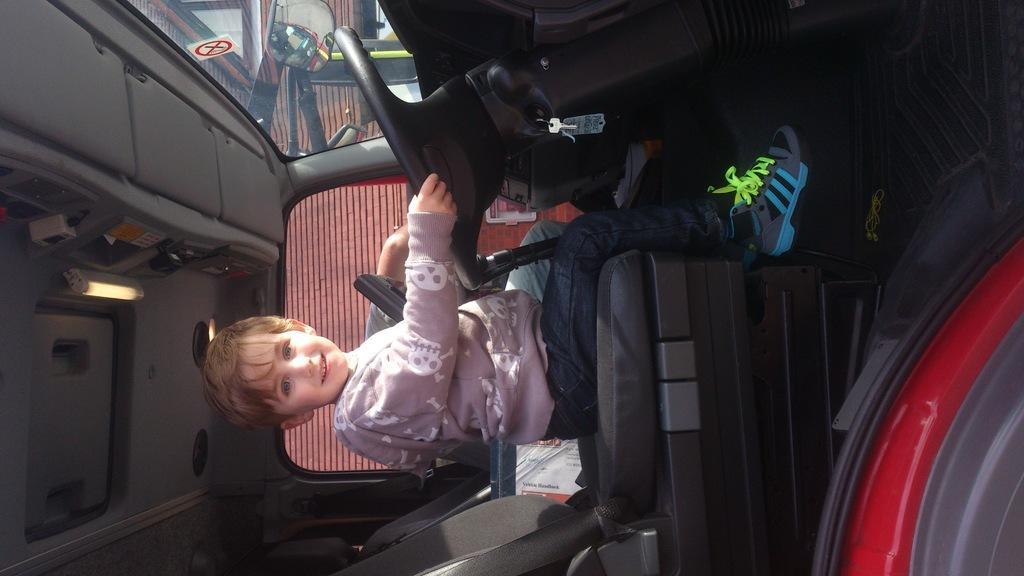Describe this image in one or two sentences. This is a picture of inside of the vehicle, in this image there is one boy who is sitting and there are some books. And in the background there is a building and mirrors. 